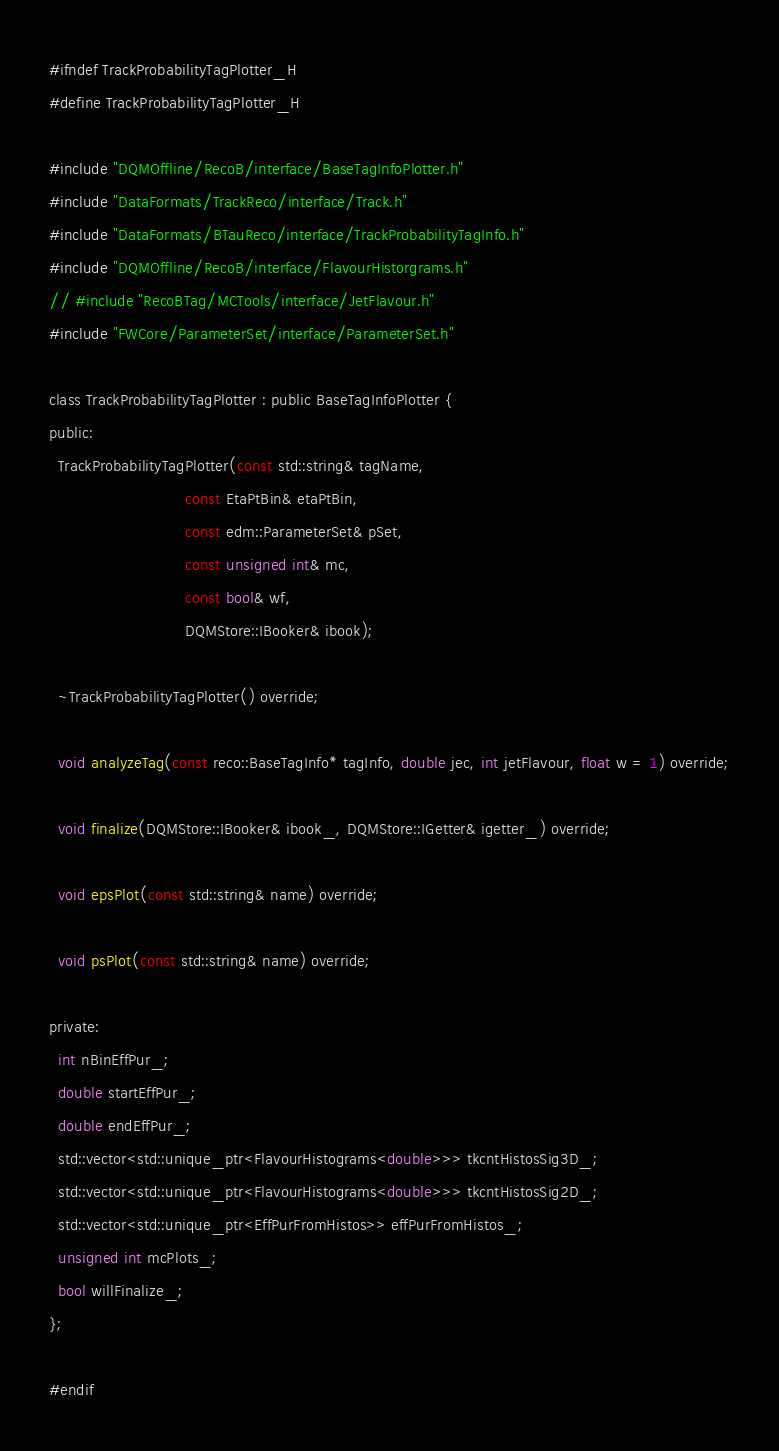<code> <loc_0><loc_0><loc_500><loc_500><_C_>#ifndef TrackProbabilityTagPlotter_H
#define TrackProbabilityTagPlotter_H

#include "DQMOffline/RecoB/interface/BaseTagInfoPlotter.h"
#include "DataFormats/TrackReco/interface/Track.h"
#include "DataFormats/BTauReco/interface/TrackProbabilityTagInfo.h"
#include "DQMOffline/RecoB/interface/FlavourHistorgrams.h"
// #include "RecoBTag/MCTools/interface/JetFlavour.h"
#include "FWCore/ParameterSet/interface/ParameterSet.h"

class TrackProbabilityTagPlotter : public BaseTagInfoPlotter {
public:
  TrackProbabilityTagPlotter(const std::string& tagName,
                             const EtaPtBin& etaPtBin,
                             const edm::ParameterSet& pSet,
                             const unsigned int& mc,
                             const bool& wf,
                             DQMStore::IBooker& ibook);

  ~TrackProbabilityTagPlotter() override;

  void analyzeTag(const reco::BaseTagInfo* tagInfo, double jec, int jetFlavour, float w = 1) override;

  void finalize(DQMStore::IBooker& ibook_, DQMStore::IGetter& igetter_) override;

  void epsPlot(const std::string& name) override;

  void psPlot(const std::string& name) override;

private:
  int nBinEffPur_;
  double startEffPur_;
  double endEffPur_;
  std::vector<std::unique_ptr<FlavourHistograms<double>>> tkcntHistosSig3D_;
  std::vector<std::unique_ptr<FlavourHistograms<double>>> tkcntHistosSig2D_;
  std::vector<std::unique_ptr<EffPurFromHistos>> effPurFromHistos_;
  unsigned int mcPlots_;
  bool willFinalize_;
};

#endif
</code> 